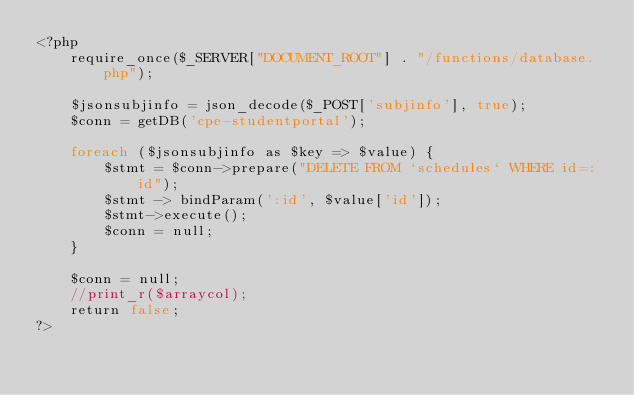<code> <loc_0><loc_0><loc_500><loc_500><_PHP_><?php	
	require_once($_SERVER["DOCUMENT_ROOT"] . "/functions/database.php");

	$jsonsubjinfo = json_decode($_POST['subjinfo'], true);
	$conn = getDB('cpe-studentportal');
			
	foreach ($jsonsubjinfo as $key => $value) {	
		$stmt = $conn->prepare("DELETE FROM `schedules` WHERE id=:id");
		$stmt -> bindParam(':id', $value['id']);
		$stmt->execute();	
		$conn = null;	
	}
	
	$conn = null;	
	//print_r($arraycol);
	return false;
?></code> 